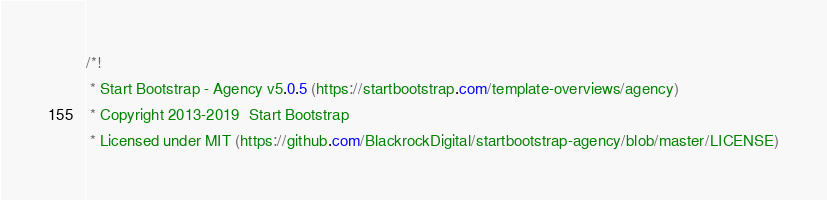<code> <loc_0><loc_0><loc_500><loc_500><_CSS_>/*!
 * Start Bootstrap - Agency v5.0.5 (https://startbootstrap.com/template-overviews/agency)
 * Copyright 2013-2019  Start Bootstrap
 * Licensed under MIT (https://github.com/BlackrockDigital/startbootstrap-agency/blob/master/LICENSE)</code> 